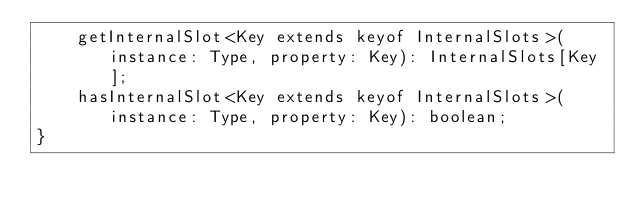<code> <loc_0><loc_0><loc_500><loc_500><_TypeScript_>	getInternalSlot<Key extends keyof InternalSlots>(instance: Type, property: Key): InternalSlots[Key];
	hasInternalSlot<Key extends keyof InternalSlots>(instance: Type, property: Key): boolean;
}
</code> 